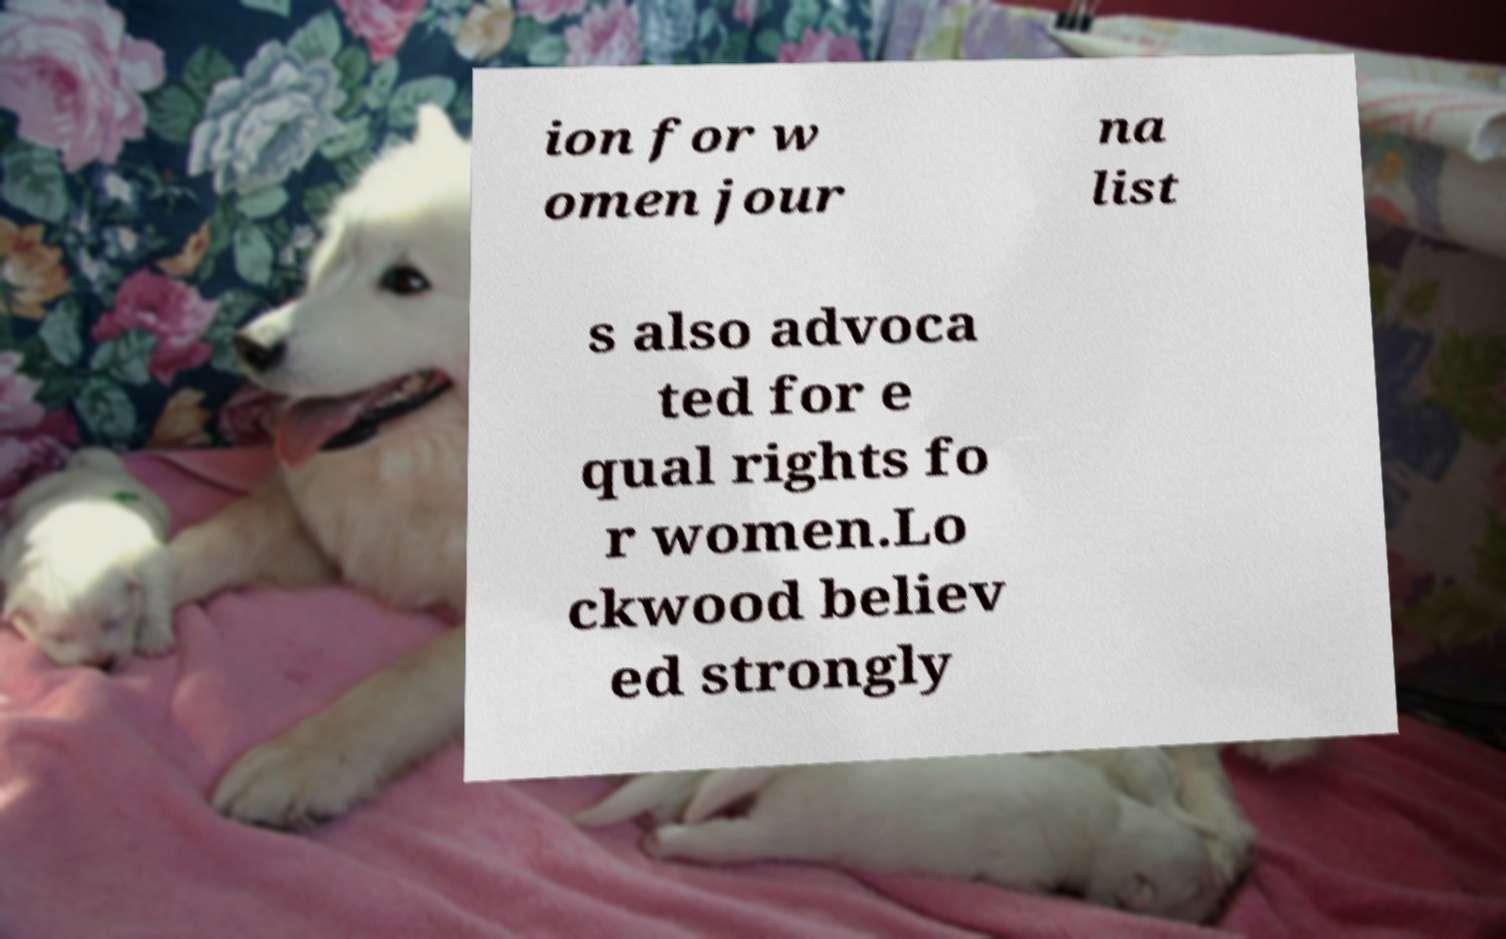Please read and relay the text visible in this image. What does it say? ion for w omen jour na list s also advoca ted for e qual rights fo r women.Lo ckwood believ ed strongly 